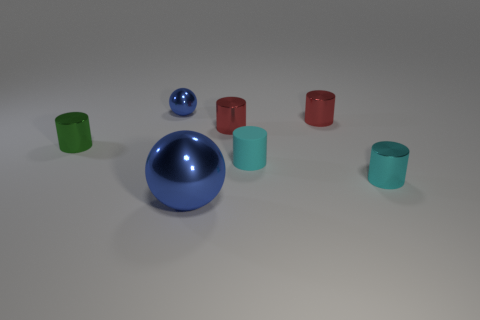How big is the blue metal object right of the blue metal object that is to the left of the blue object right of the tiny blue metallic thing?
Keep it short and to the point. Large. There is another thing that is the same shape as the large blue thing; what is its material?
Your answer should be very brief. Metal. Are there any other things that have the same size as the cyan metal cylinder?
Provide a succinct answer. Yes. What is the size of the blue object in front of the metal thing that is on the left side of the small metallic sphere?
Make the answer very short. Large. What is the color of the big object?
Your answer should be compact. Blue. There is a blue shiny thing to the left of the big metal object; how many cylinders are right of it?
Provide a succinct answer. 4. Are there any shiny things in front of the blue shiny ball that is behind the big thing?
Your answer should be very brief. Yes. There is a tiny cyan rubber cylinder; are there any tiny cylinders on the left side of it?
Offer a very short reply. Yes. There is a blue metallic object that is behind the green metallic thing; does it have the same shape as the green metallic thing?
Your response must be concise. No. How many small red metallic things are the same shape as the small green shiny object?
Offer a very short reply. 2. 